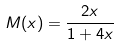Convert formula to latex. <formula><loc_0><loc_0><loc_500><loc_500>M ( x ) = \frac { 2 x } { 1 + 4 x }</formula> 